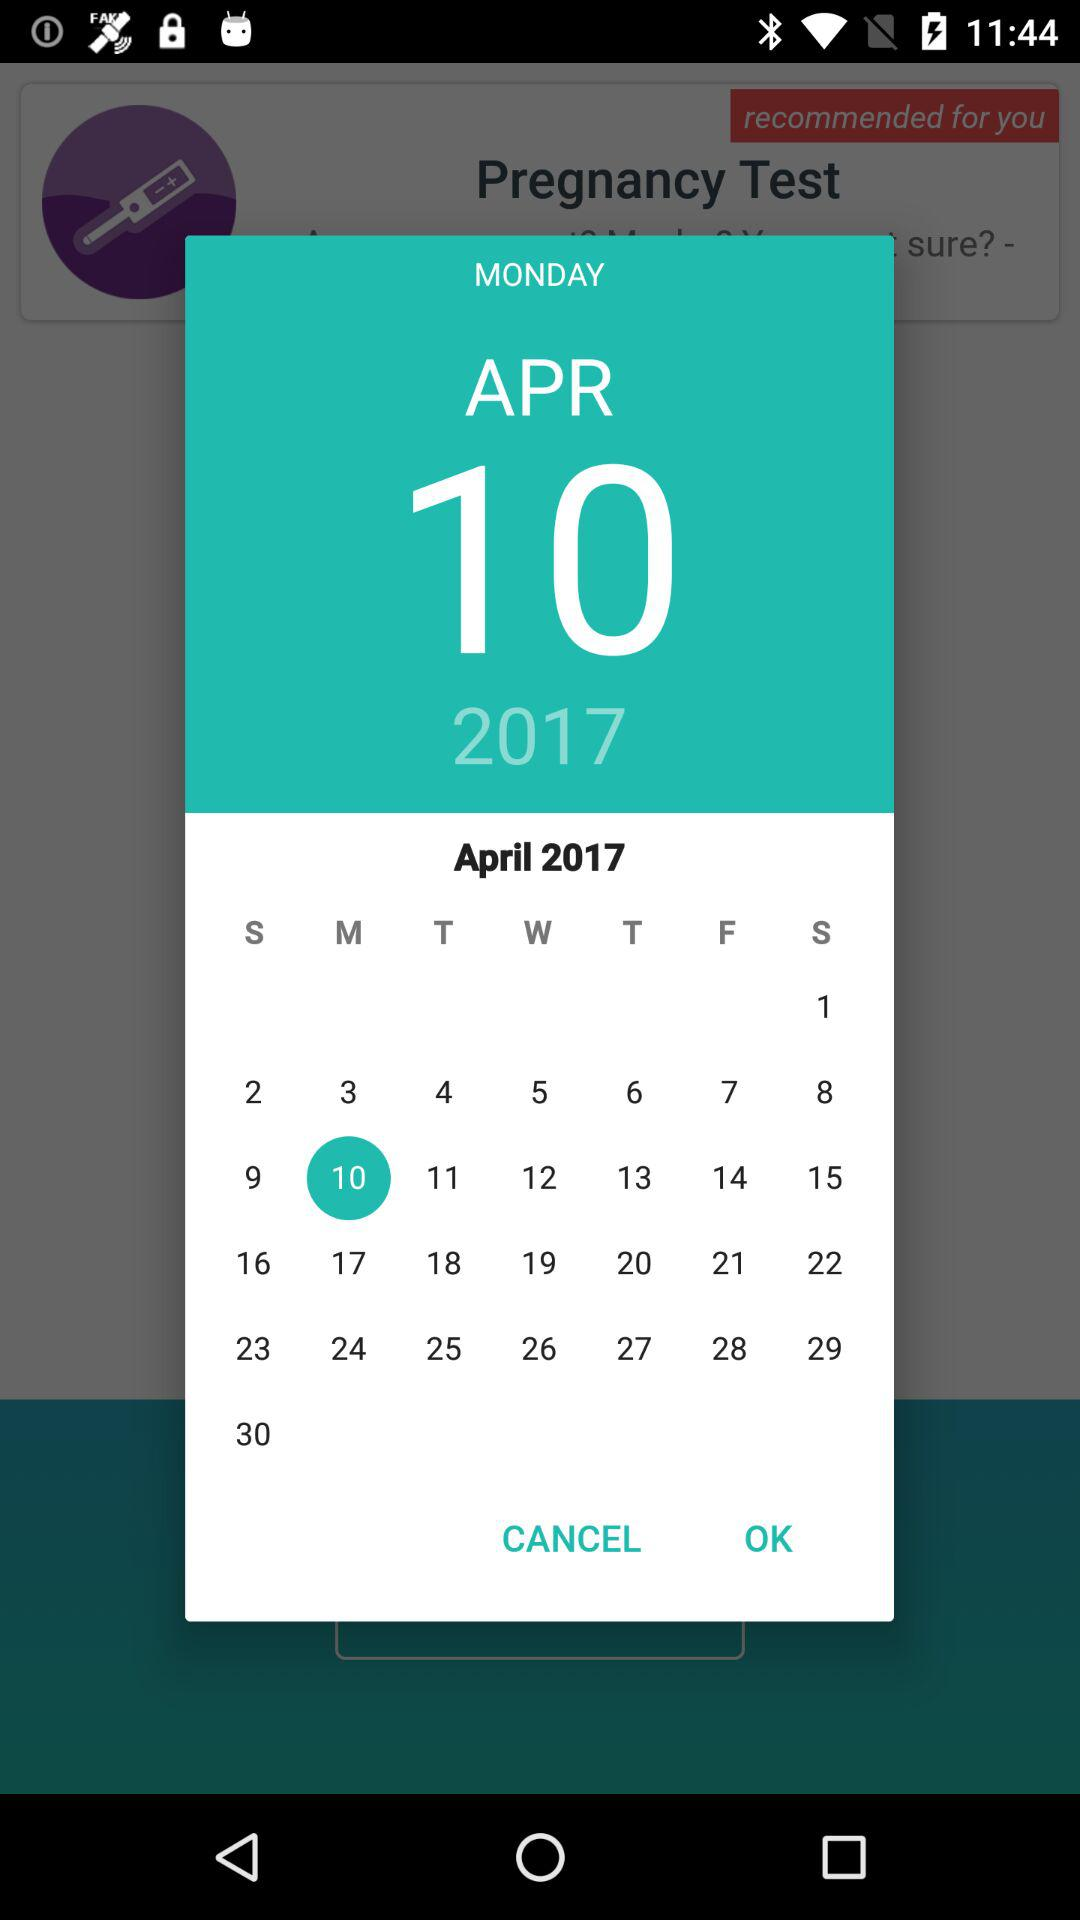Which holiday falls on Monday, April 10, 2017?
When the provided information is insufficient, respond with <no answer>. <no answer> 